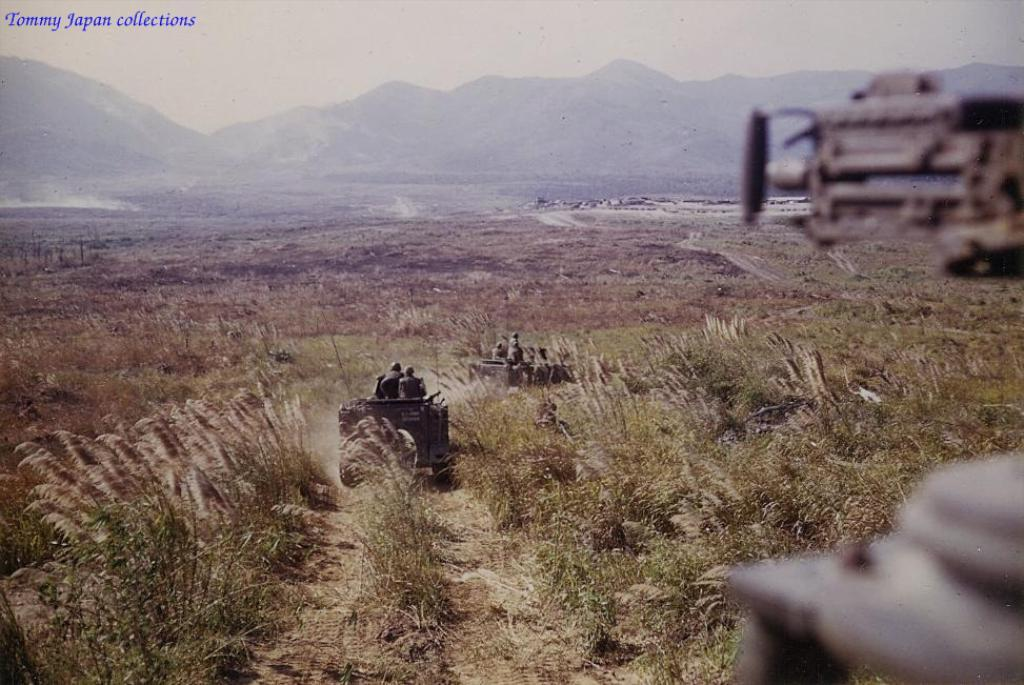What type of vehicles are present in the image? There are army vehicles in the image. Where are the army vehicles located? The army vehicles are on the grass. What can be seen beneath the army vehicles? The ground is visible in the image. What type of polish is being applied to the scarf in the image? There is no polish or scarf present in the image; it features army vehicles on the grass. 